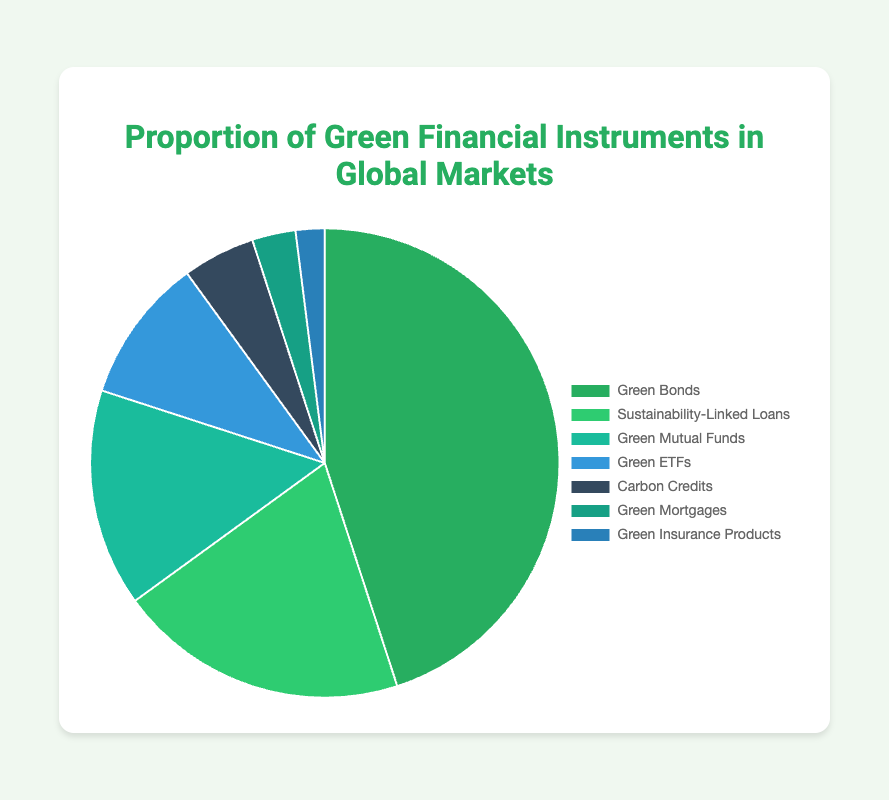What is the proportion of the largest green financial instrument in the global markets? The largest green financial instrument in the global markets is Green Bonds, which occupies 45% of the total market as indicated in the figure's data.
Answer: 45% Which green financial instrument has the smallest proportion, and what is it? The smallest proportion is held by Green Insurance Products, which occupy 2% of the total market. The figure shows various financial instruments with their respective proportions, and Green Insurance Products is the smallest slice in the pie chart.
Answer: Green Insurance Products, 2% What is the combined proportion of Green ETFs and Carbon Credits? To find the combined proportion, we need to add the individual proportions of Green ETFs (10%) and Carbon Credits (5%). The sum is 10% + 5% = 15%.
Answer: 15% Are Green Bonds' proportions greater than the combined proportions of Green Mutual Funds and Sustainability-Linked Loans? First, add the proportions of Green Mutual Funds (15%) and Sustainability-Linked Loans (20%), which gives 15% + 20% = 35%. Since Green Bonds have a proportion of 45%, which is greater than 35%, the answer is yes.
Answer: Yes Which financial instrument has a proportion of 15% and what is its color in the pie chart? The financial instrument with a proportion of 15% is Green Mutual Funds. According to the chart information, Green Mutual Funds are represented by a shade of green. The shade used in the data corresponds to the color '#1abc9c'.
Answer: Green Mutual Funds, a shade of green How much larger is the proportion of Green Bonds compared to Green Insurance Products? The proportion of Green Bonds (45%) is larger than Green Insurance Products (2%) by subtracting the smaller from the larger: 45% - 2% = 43%.
Answer: 43% What is the proportion difference between Green Mortgages and Green ETFs? Subtract the proportion of Green Mortgages (3%) from that of Green ETFs (10%): 10% - 3% = 7%.
Answer: 7% How many green financial instruments have a proportion of 10% or less? The proportionate values of Green ETFs (10%), Carbon Credits (5%), Green Mortgages (3%), and Green Insurance Products (2%) are all 10% or less. There are four such instruments.
Answer: 4 What is the average proportion of Sustainability-Linked Loans, Green Mutual Funds, and Carbon Credits? Add the proportions of Sustainability-Linked Loans (20%), Green Mutual Funds (15%), and Carbon Credits (5%) to get a total of 20% + 15% + 5% = 40%. Divide by the number of instruments (3) to get the average: 40% / 3 ≈ 13.33%.
Answer: 13.33% 